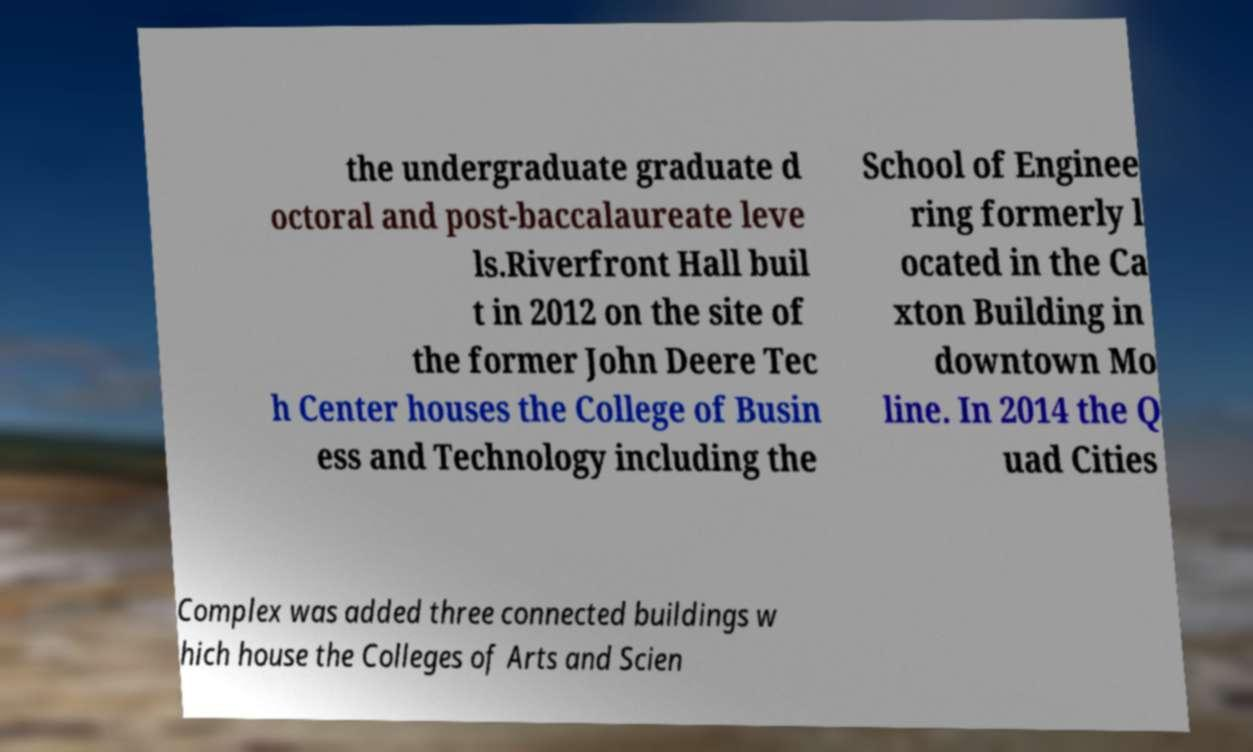Can you read and provide the text displayed in the image?This photo seems to have some interesting text. Can you extract and type it out for me? the undergraduate graduate d octoral and post-baccalaureate leve ls.Riverfront Hall buil t in 2012 on the site of the former John Deere Tec h Center houses the College of Busin ess and Technology including the School of Enginee ring formerly l ocated in the Ca xton Building in downtown Mo line. In 2014 the Q uad Cities Complex was added three connected buildings w hich house the Colleges of Arts and Scien 